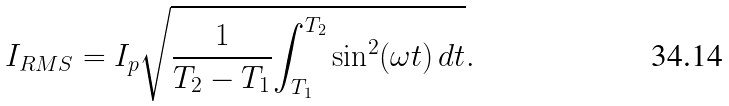<formula> <loc_0><loc_0><loc_500><loc_500>I _ { R M S } = I _ { p } { \sqrt { { \frac { 1 } { T _ { 2 } - T _ { 1 } } } { \int _ { T _ { 1 } } ^ { T _ { 2 } } { \sin ^ { 2 } ( \omega t ) } \, d t } } } .</formula> 